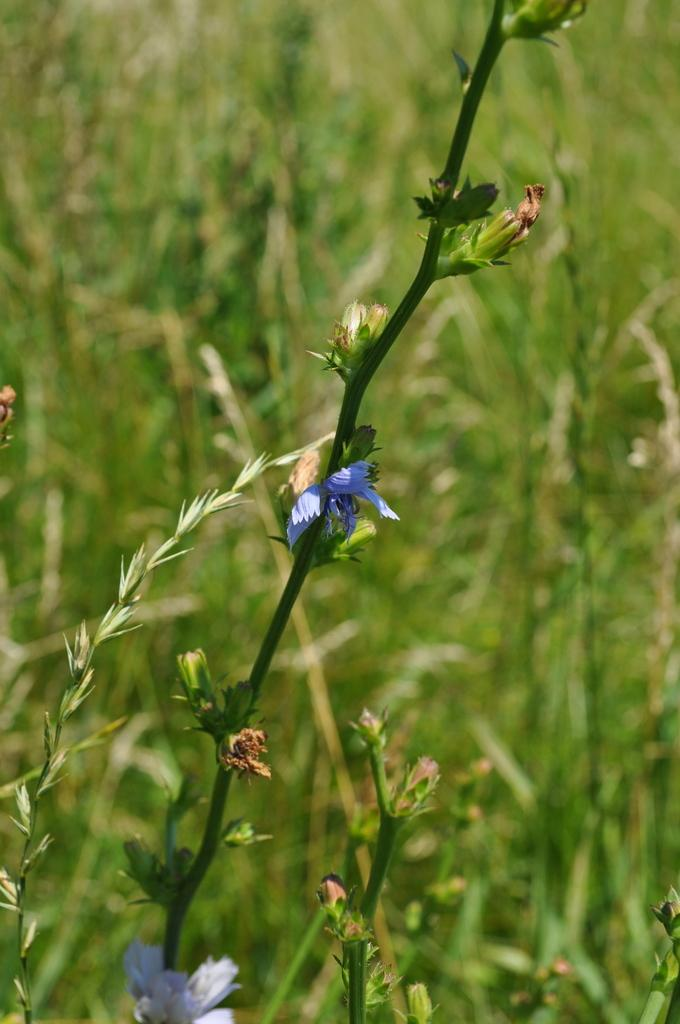What type of plants can be seen in the image? There are flowers in the image. What part of the flowers is visible in the image? There are stems in the image. What can be seen in the background of the image? There is grass visible in the background of the image. What type of design can be seen on the glass in the image? There is no glass present in the image; it only features flowers and stems. 